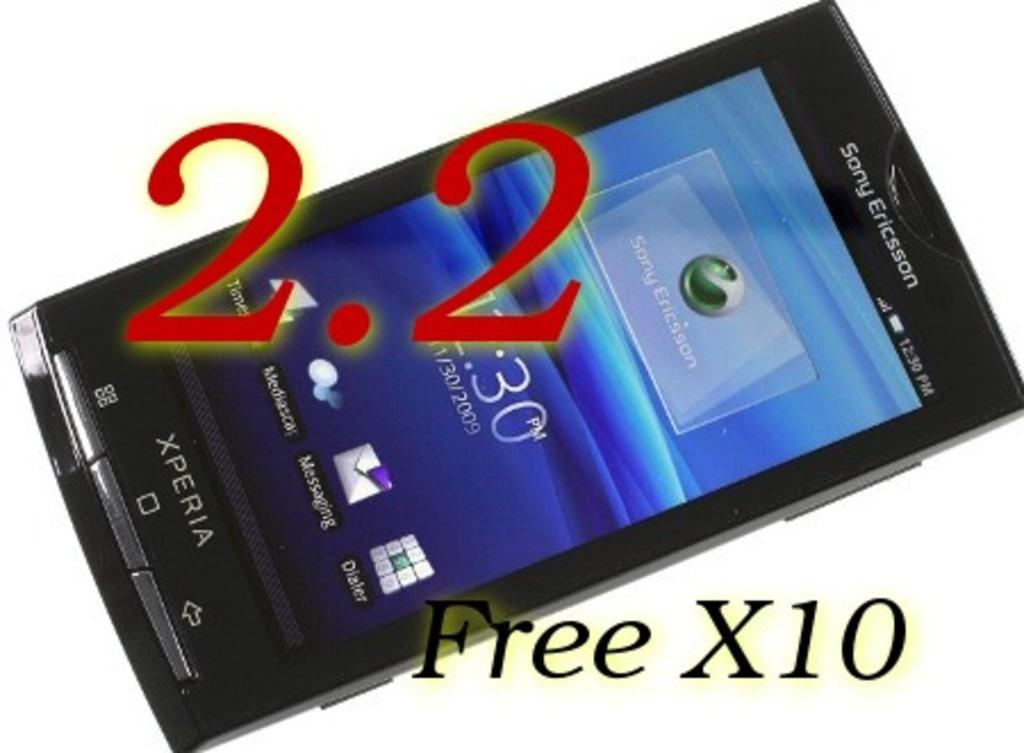Provide a one-sentence caption for the provided image. an iphone with Free X10 written at the bottom. 